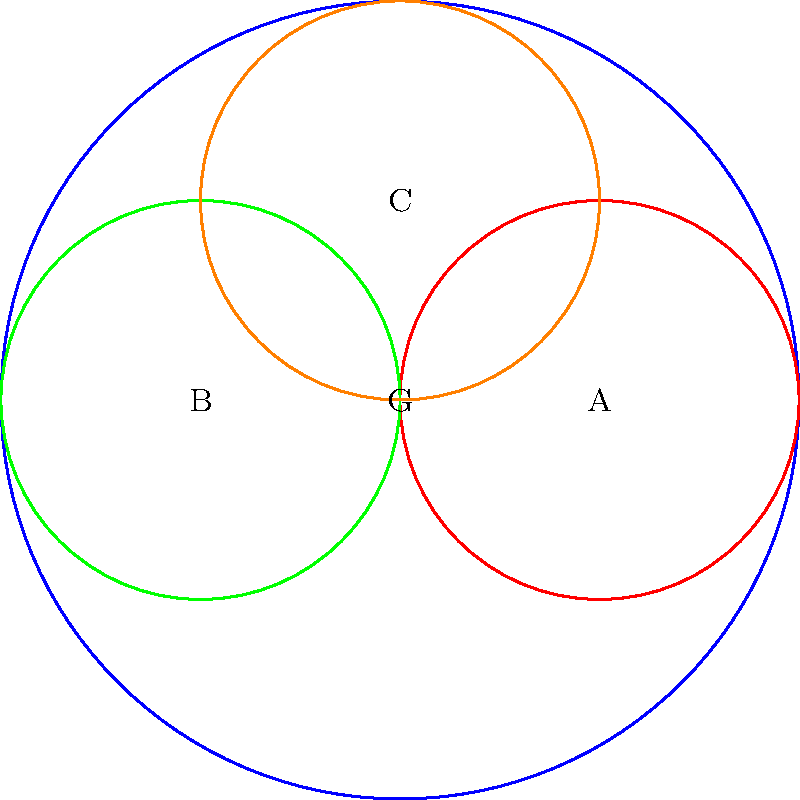Given the Venn diagram representing a group G of environmental protection measures and its subgroups A, B, and C, which combination of subgroups would likely have the most comprehensive impact on reducing industrial pollutants? Assume that the size of each circle represents the effectiveness of the measures. To answer this question, we need to analyze the subgroups and their relationships within the main group G. Let's break it down step-by-step:

1. Group G represents all environmental protection measures.
2. Subgroups A, B, and C represent different sets of measures within G.
3. The size of each circle represents the effectiveness of the measures.

Now, let's examine the relationships:

4. Subgroups A and B are of equal size, indicating similar levels of effectiveness.
5. Subgroup C is also the same size as A and B.
6. All three subgroups (A, B, and C) are contained within G, but they don't completely cover G.
7. There are areas where the subgroups overlap, suggesting some measures are shared between them.

To have the most comprehensive impact on reducing industrial pollutants, we should consider the combination that covers the largest area within G:

8. The combination of A, B, and C together would cover the largest area within G.
9. This combination would include measures from all three subgroups, potentially addressing different aspects of environmental protection.
10. The overlapping areas suggest that some measures might be reinforced or complementary across subgroups.

Therefore, the most comprehensive impact would likely come from implementing measures from all three subgroups A, B, and C together.
Answer: A ∪ B ∪ C 